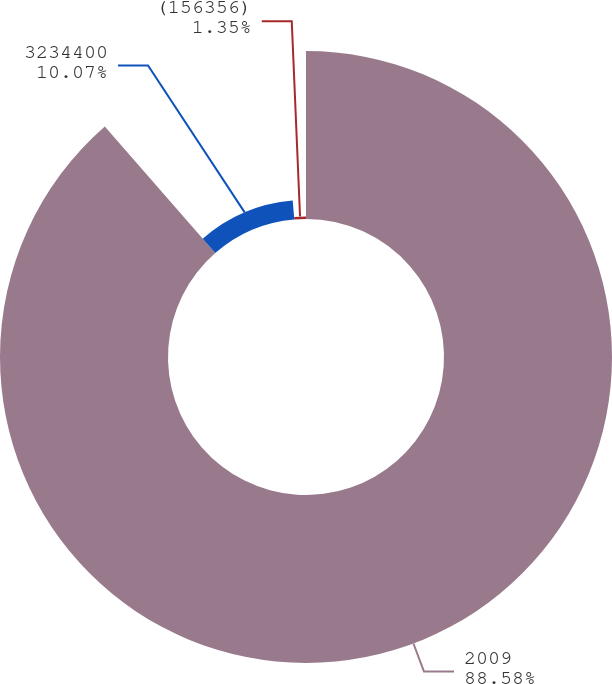Convert chart. <chart><loc_0><loc_0><loc_500><loc_500><pie_chart><fcel>2009<fcel>3234400<fcel>(156356)<nl><fcel>88.58%<fcel>10.07%<fcel>1.35%<nl></chart> 